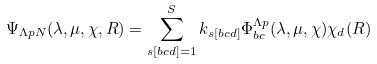<formula> <loc_0><loc_0><loc_500><loc_500>\Psi _ { \Lambda p N } ( \lambda , \mu , \chi , R ) = \sum _ { s [ b c d ] = 1 } ^ { S } k _ { s [ b c d ] } \Phi _ { b c } ^ { \Lambda p } ( \lambda , \mu , \chi ) \chi _ { d } ( R )</formula> 